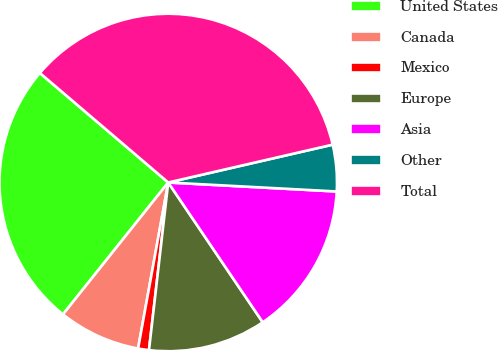Convert chart to OTSL. <chart><loc_0><loc_0><loc_500><loc_500><pie_chart><fcel>United States<fcel>Canada<fcel>Mexico<fcel>Europe<fcel>Asia<fcel>Other<fcel>Total<nl><fcel>25.52%<fcel>7.86%<fcel>1.04%<fcel>11.28%<fcel>14.69%<fcel>4.45%<fcel>35.16%<nl></chart> 